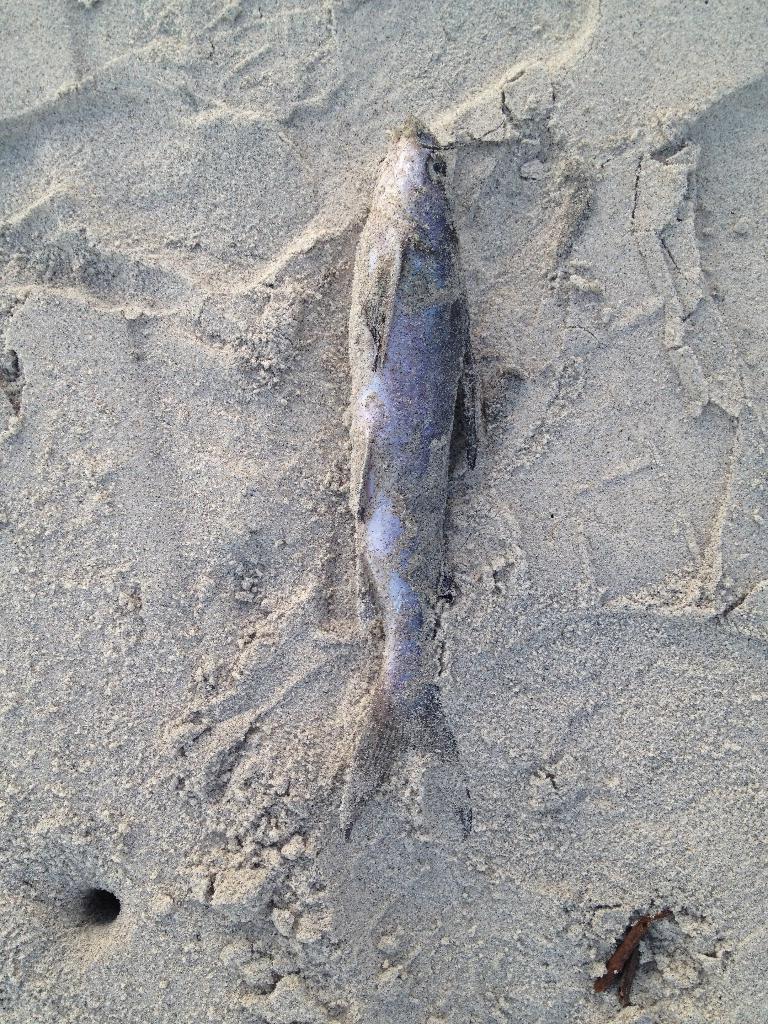In one or two sentences, can you explain what this image depicts? In the center of the image we can see one fish on the sand. In the bottom right side of the image, we can see one brown color object. 